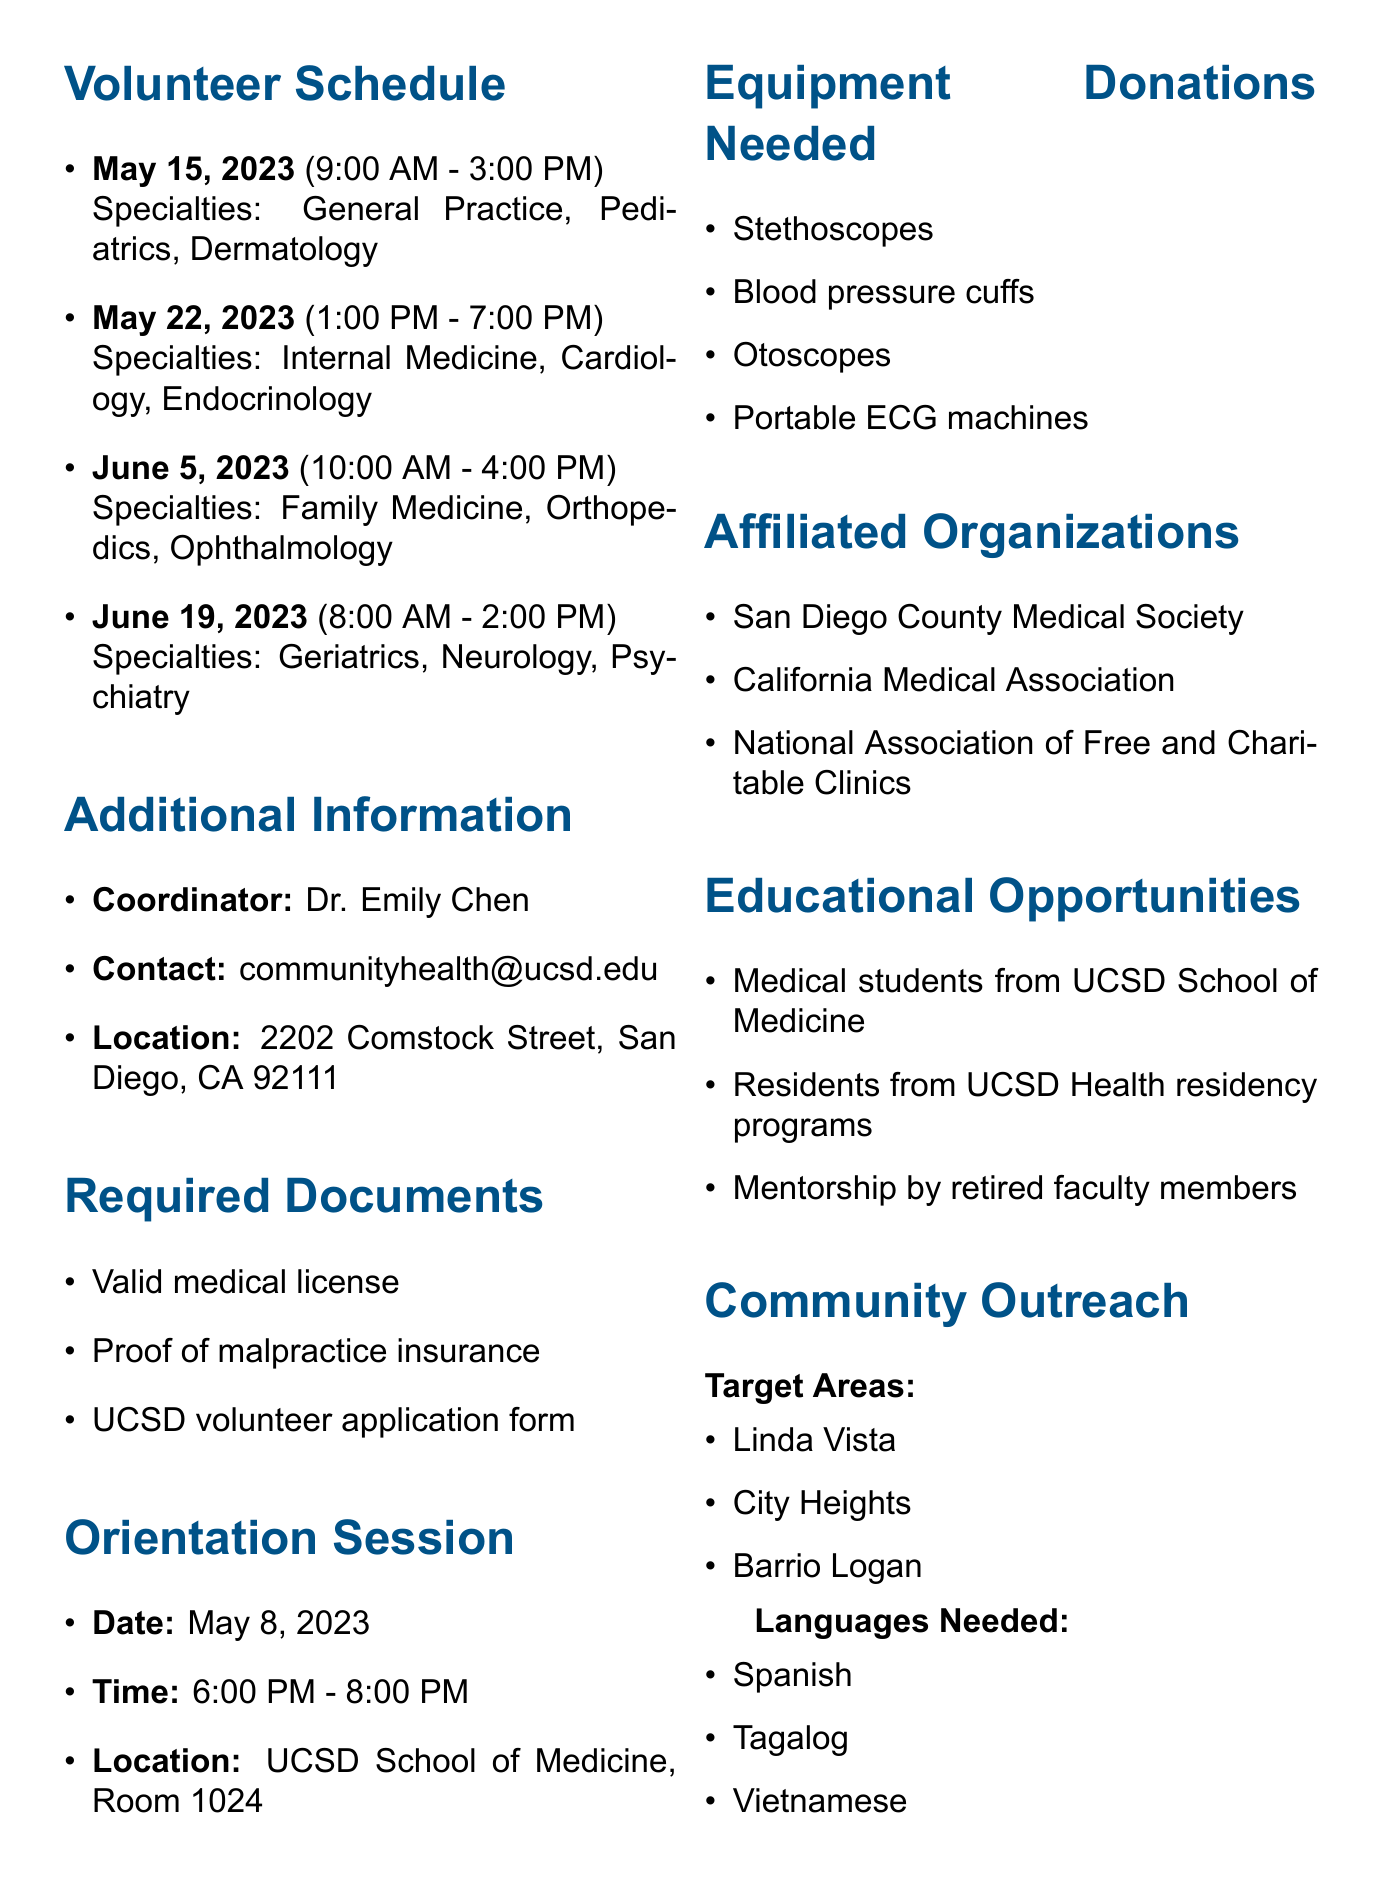What is the next scheduled date for the clinic? The next scheduled date for the clinic after the orientation session is May 15, 2023.
Answer: May 15, 2023 Who is the coordinator for the clinic? The document names Dr. Emily Chen as the coordinator for the clinic.
Answer: Dr. Emily Chen What time does the clinic open on May 22, 2023? The clinic opens at 1:00 PM on May 22, 2023.
Answer: 1:00 PM How many medical specialties are required on June 5, 2023? The document lists three specialties needed for the June 5, 2023 session.
Answer: Three What is the location of the orientation session? The orientation session is held at UCSD School of Medicine, Room 1024.
Answer: UCSD School of Medicine, Room 1024 Which medical specialties are needed on May 15, 2023? The specialties needed on May 15, 2023, are General Practice, Pediatrics, and Dermatology.
Answer: General Practice, Pediatrics, Dermatology Which languages are identified as necessary for community outreach? The document specifies Spanish, Tagalog, and Vietnamese as the required languages.
Answer: Spanish, Tagalog, Vietnamese What type of volunteers are involved from UCSD? The document mentions medical students from UCSD School of Medicine as student volunteers.
Answer: Medical students What documents are required to volunteer? Required documents include a valid medical license, proof of malpractice insurance, and UCSD volunteer application form.
Answer: Valid medical license, proof of malpractice insurance, UCSD volunteer application form 